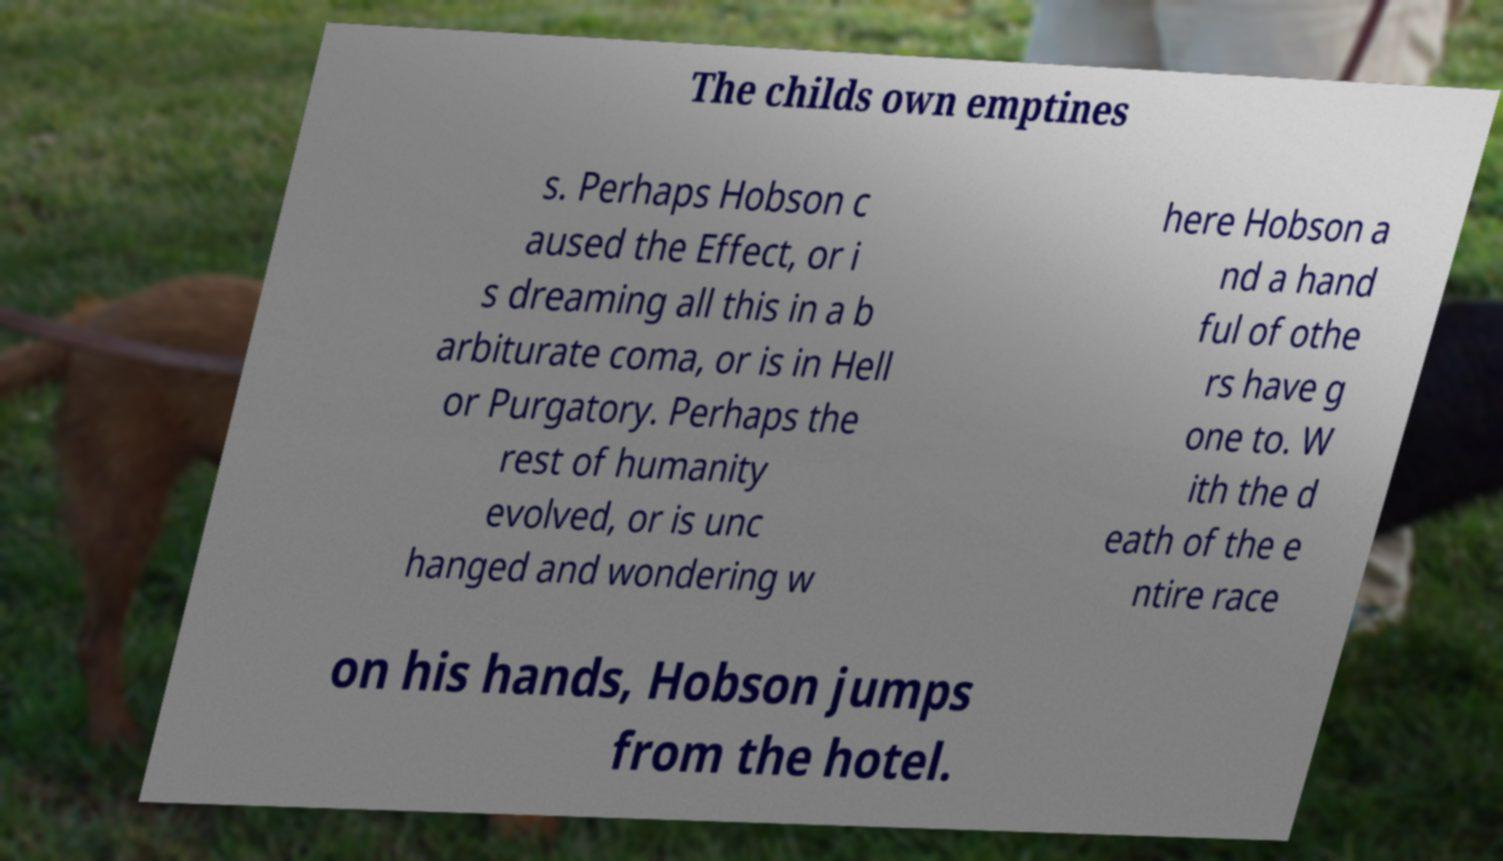Please identify and transcribe the text found in this image. The childs own emptines s. Perhaps Hobson c aused the Effect, or i s dreaming all this in a b arbiturate coma, or is in Hell or Purgatory. Perhaps the rest of humanity evolved, or is unc hanged and wondering w here Hobson a nd a hand ful of othe rs have g one to. W ith the d eath of the e ntire race on his hands, Hobson jumps from the hotel. 